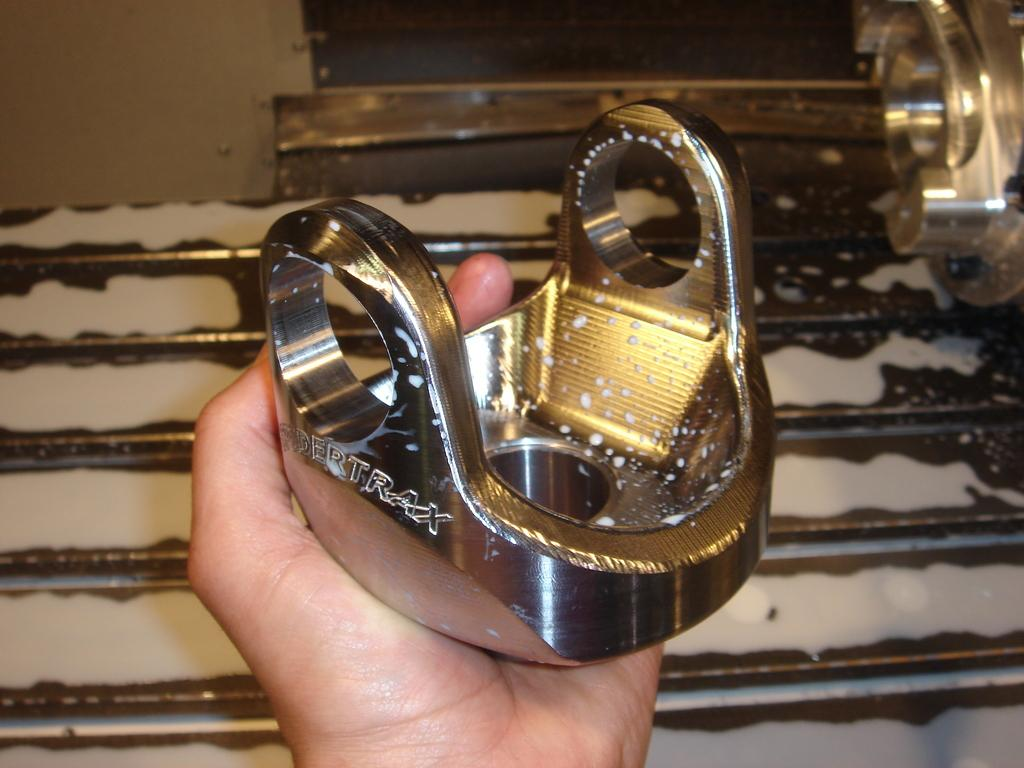What is the hand holding in the middle of the image? The fact provided does not specify what the hand is holding. What type of objects can be seen on the right side of the image? There are steel instruments on the right side of the image. What is visible in the background of the image? There is a wall in the background of the image. How many rods are being twisted by the hand in the image? There are no rods present in the image, and the hand is not shown twisting anything. 